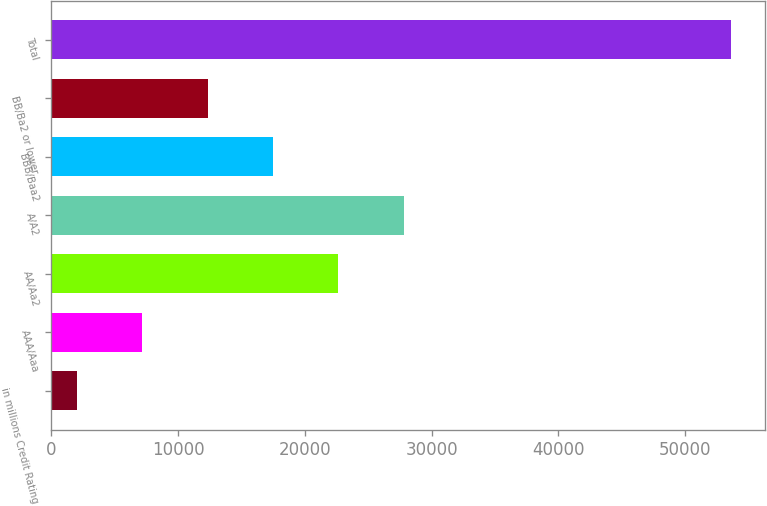Convert chart. <chart><loc_0><loc_0><loc_500><loc_500><bar_chart><fcel>in millions Credit Rating<fcel>AAA/Aaa<fcel>AA/Aa2<fcel>A/A2<fcel>BBB/Baa2<fcel>BB/Ba2 or lower<fcel>Total<nl><fcel>2013<fcel>7171.9<fcel>22648.6<fcel>27807.5<fcel>17489.7<fcel>12330.8<fcel>53602<nl></chart> 